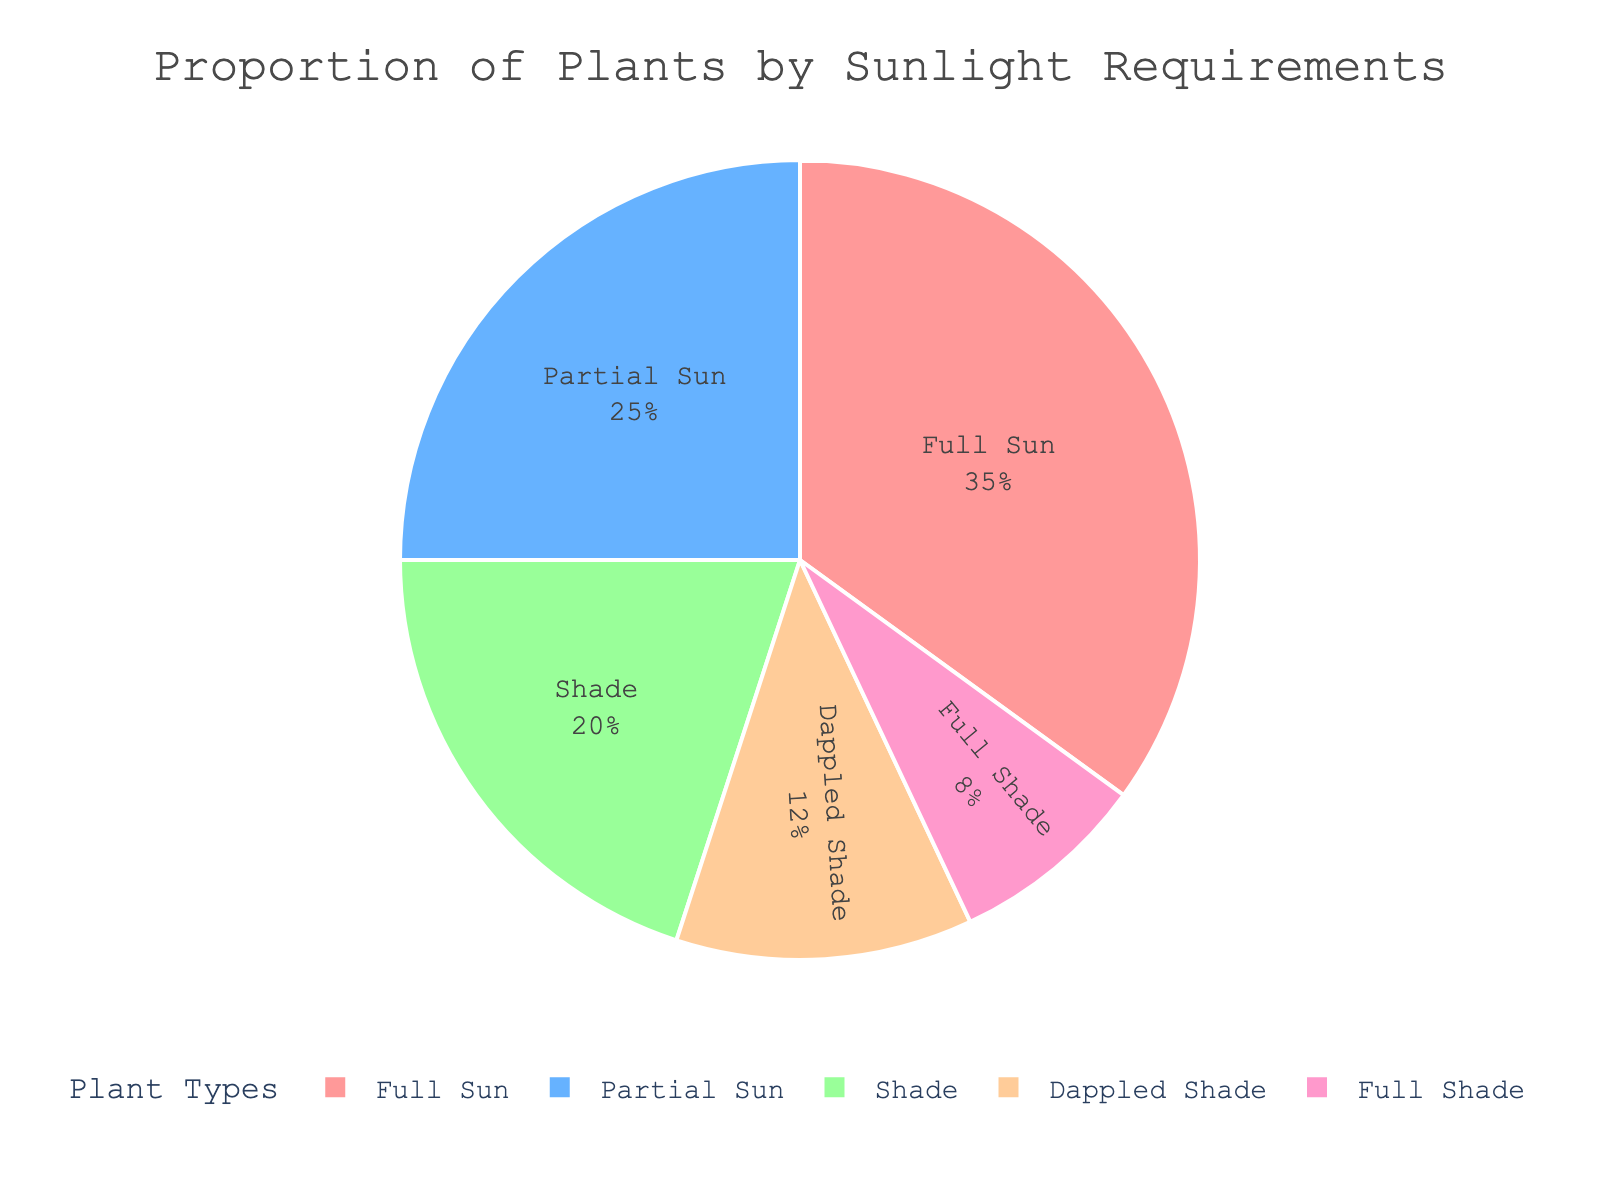Which plant type requires the most sunlight? The figure shows a pie chart with different plant types and their sunlight requirements. Full Sun has the largest portion of the pie.
Answer: Full Sun What percentage of plants require dappled shade? The pie chart displays percentages for each plant type. Dappled Shade is labeled with 12%.
Answer: 12% How much greater is the percentage of plants requiring Full Sun compared to those requiring Full Shade? Full Sun has 35%, and Full Shade has 8%. The difference is 35% - 8%.
Answer: 27% Which plant type has a smaller percentage, Shade or Full Shade? The chart shows Shade with 20% and Full Shade with 8%.
Answer: Full Shade What is the combined percentage of plants that require Partial Sun and Dappled Shade? Partial Sun accounts for 25%, and Dappled Shade accounts for 12%. Their sum is 25% + 12%.
Answer: 37% Which two plant types account for a total of 45%? The chart shows Full Sun at 35% and Partial Sun at 25%. These add up to 60%. Checking the next combination, Partial Sun at 25% and Shade at 20%, which sum to 45%.
Answer: Partial Sun and Shade Which plant type occupies the smallest segment of the pie chart? The pie chart indicates that Full Shade has the smallest portion, at 8%.
Answer: Full Shade How much more of a percentage do plants requiring Full Sun have compared to those requiring Partial Sun? Full Sun has 35%, and Partial Sun has 25%. The difference is 35% - 25%.
Answer: 10% What is the average percentage of plants across all given sunlight requirements? The percentages are 35%, 25%, 20%, 12%, and 8%. Adding these gives 100%. There are 5 categories, so the average is 100% / 5.
Answer: 20% Which plant types combined make up more than 50% of the garden? Full Sun is 35% and Partial Sun is 25%. Adding these gives 60%.
Answer: Full Sun and Partial Sun 